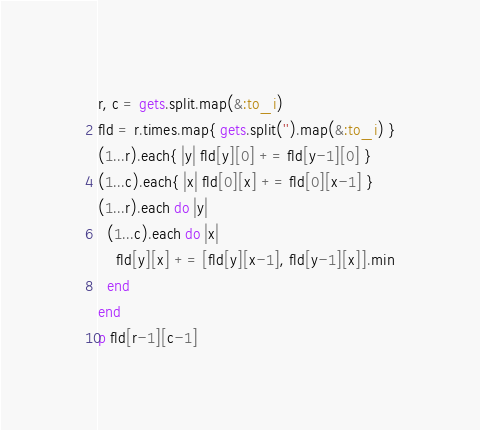<code> <loc_0><loc_0><loc_500><loc_500><_Ruby_>r, c = gets.split.map(&:to_i)
fld = r.times.map{ gets.split('').map(&:to_i) }
(1...r).each{ |y| fld[y][0] += fld[y-1][0] }
(1...c).each{ |x| fld[0][x] += fld[0][x-1] }
(1...r).each do |y|
  (1...c).each do |x|
    fld[y][x] += [fld[y][x-1], fld[y-1][x]].min
  end
end
p fld[r-1][c-1]</code> 